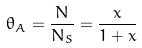<formula> <loc_0><loc_0><loc_500><loc_500>\theta _ { A } = \frac { N } { N _ { S } } = \frac { x } { 1 + x }</formula> 